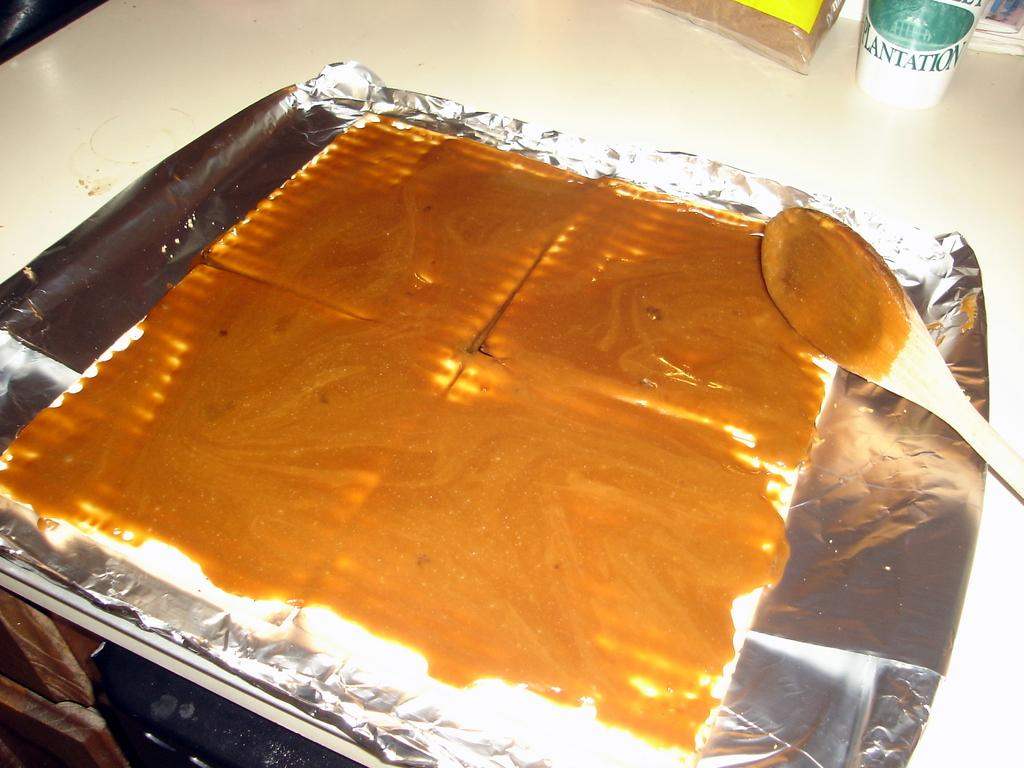<image>
Give a short and clear explanation of the subsequent image. A cup saying plantation sits beside a baking tray. 